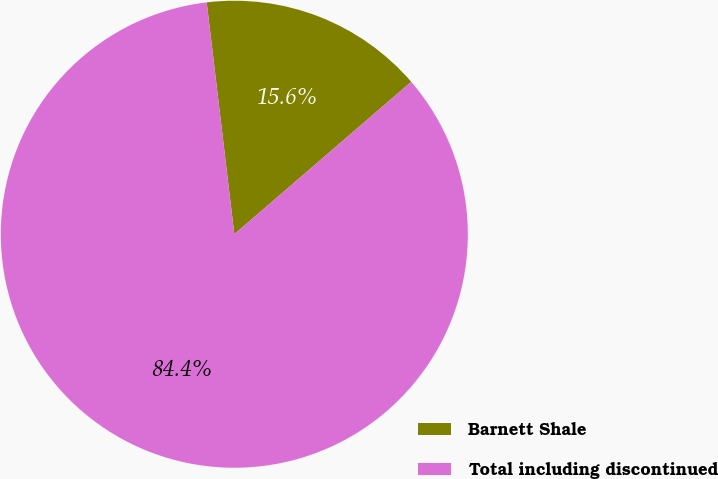Convert chart. <chart><loc_0><loc_0><loc_500><loc_500><pie_chart><fcel>Barnett Shale<fcel>Total including discontinued<nl><fcel>15.57%<fcel>84.43%<nl></chart> 